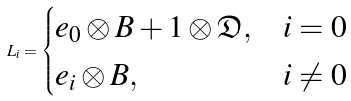Convert formula to latex. <formula><loc_0><loc_0><loc_500><loc_500>L _ { i } = \begin{cases} e _ { 0 } \otimes B + 1 \otimes \mathfrak D , & i = 0 \\ e _ { i } \otimes B , & i \ne 0 \end{cases}</formula> 